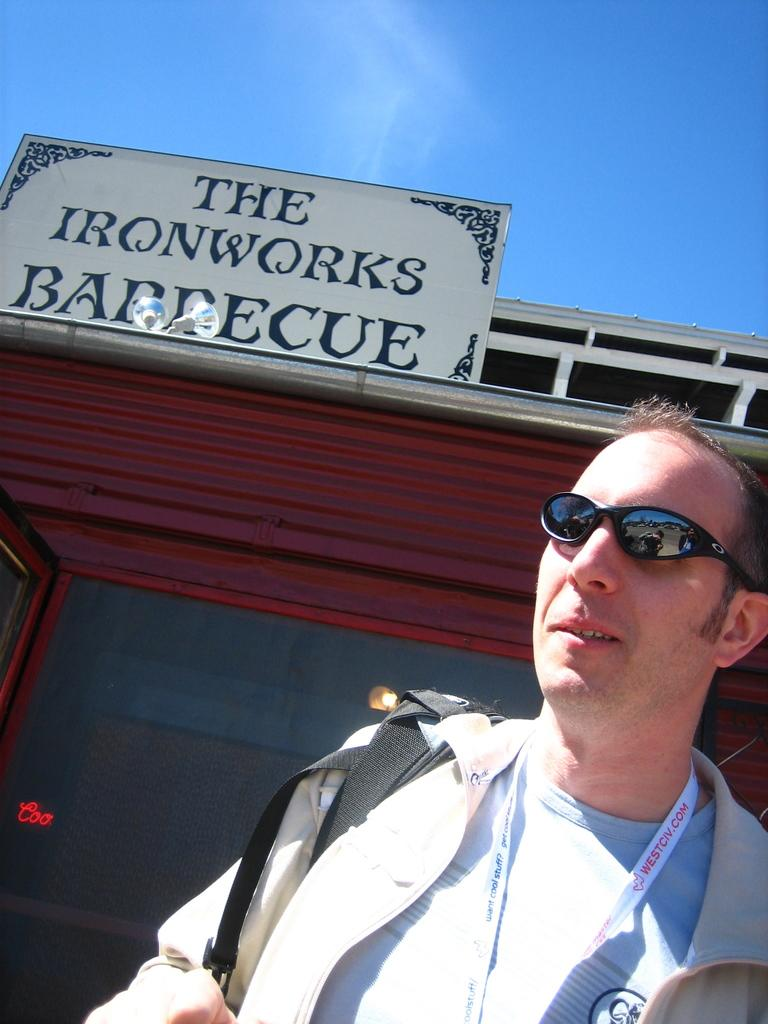Who or what is the main subject in the image? There is a person in the image. What can be seen in the background behind the person? There is a board and a building in the background of the image. What is visible at the top of the image? The sky is visible at the top of the image. What type of snakes can be seen crawling on the person's shoulders in the image? There are no snakes present in the image; the person is not accompanied by any snakes. 